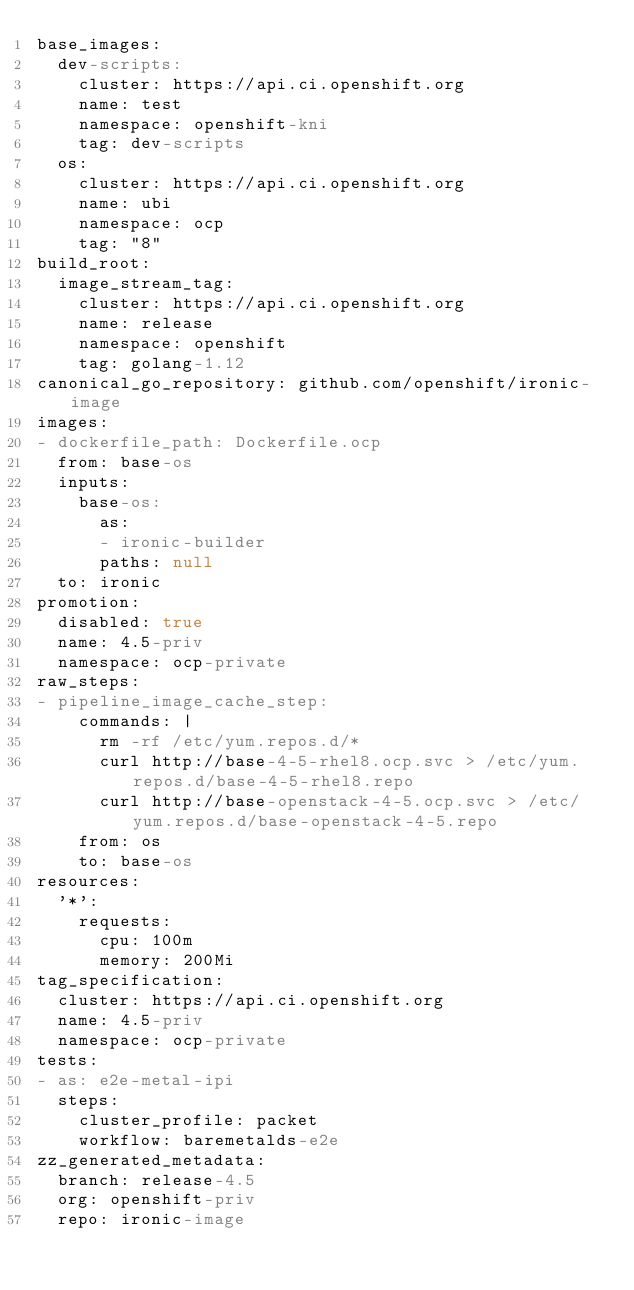<code> <loc_0><loc_0><loc_500><loc_500><_YAML_>base_images:
  dev-scripts:
    cluster: https://api.ci.openshift.org
    name: test
    namespace: openshift-kni
    tag: dev-scripts
  os:
    cluster: https://api.ci.openshift.org
    name: ubi
    namespace: ocp
    tag: "8"
build_root:
  image_stream_tag:
    cluster: https://api.ci.openshift.org
    name: release
    namespace: openshift
    tag: golang-1.12
canonical_go_repository: github.com/openshift/ironic-image
images:
- dockerfile_path: Dockerfile.ocp
  from: base-os
  inputs:
    base-os:
      as:
      - ironic-builder
      paths: null
  to: ironic
promotion:
  disabled: true
  name: 4.5-priv
  namespace: ocp-private
raw_steps:
- pipeline_image_cache_step:
    commands: |
      rm -rf /etc/yum.repos.d/*
      curl http://base-4-5-rhel8.ocp.svc > /etc/yum.repos.d/base-4-5-rhel8.repo
      curl http://base-openstack-4-5.ocp.svc > /etc/yum.repos.d/base-openstack-4-5.repo
    from: os
    to: base-os
resources:
  '*':
    requests:
      cpu: 100m
      memory: 200Mi
tag_specification:
  cluster: https://api.ci.openshift.org
  name: 4.5-priv
  namespace: ocp-private
tests:
- as: e2e-metal-ipi
  steps:
    cluster_profile: packet
    workflow: baremetalds-e2e
zz_generated_metadata:
  branch: release-4.5
  org: openshift-priv
  repo: ironic-image
</code> 